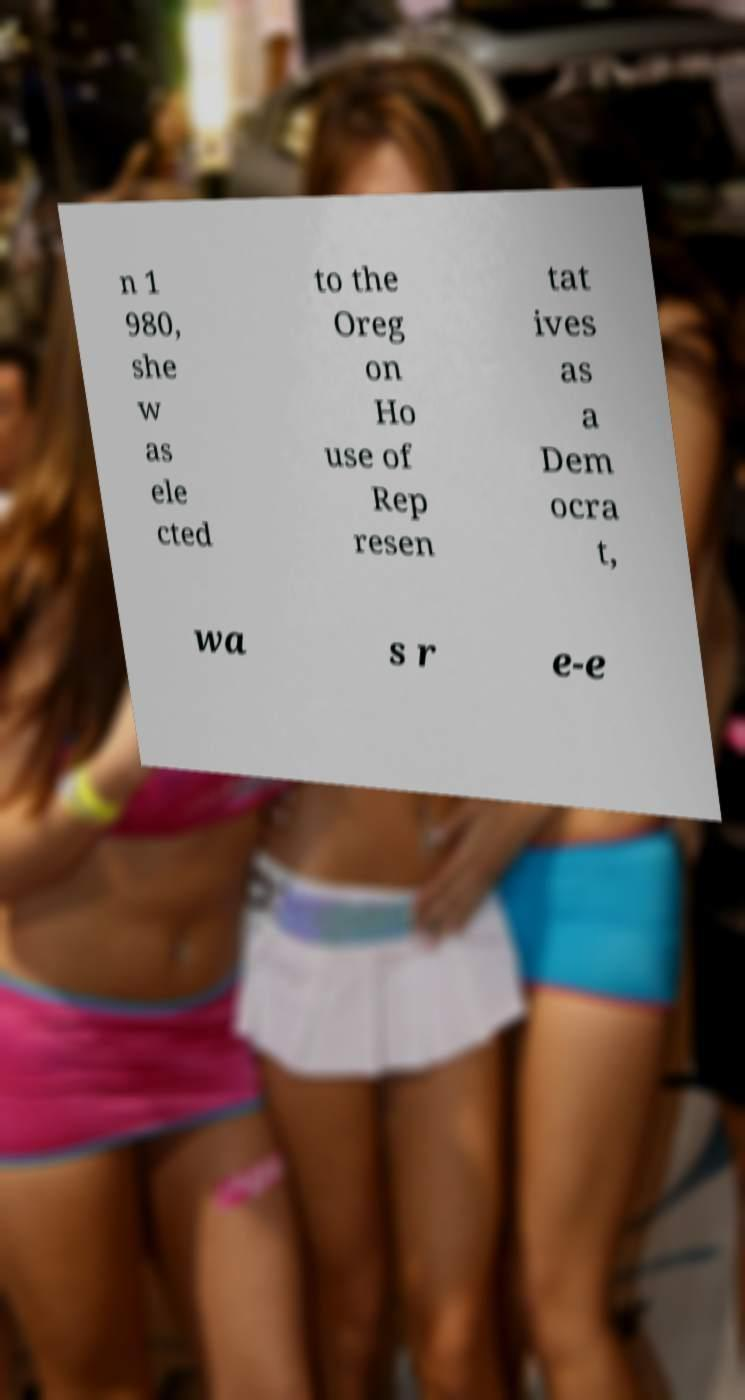Can you read and provide the text displayed in the image?This photo seems to have some interesting text. Can you extract and type it out for me? n 1 980, she w as ele cted to the Oreg on Ho use of Rep resen tat ives as a Dem ocra t, wa s r e-e 